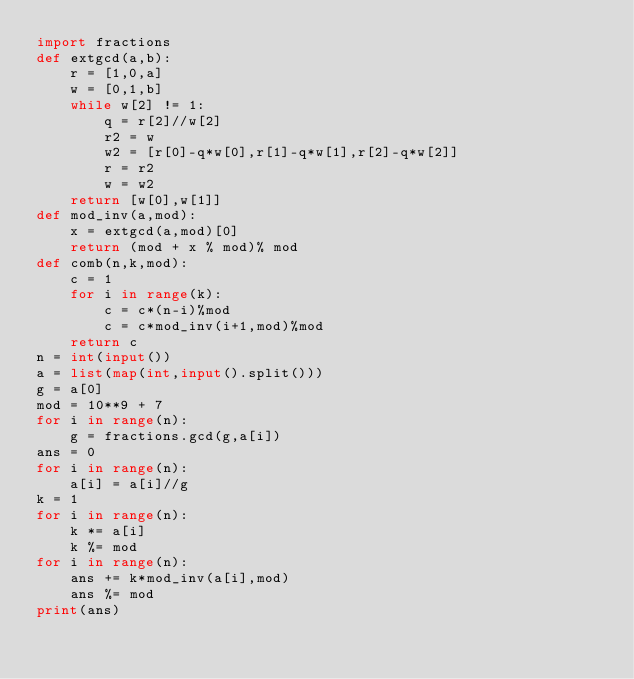<code> <loc_0><loc_0><loc_500><loc_500><_Python_>import fractions
def extgcd(a,b):
    r = [1,0,a]
    w = [0,1,b]
    while w[2] != 1:
        q = r[2]//w[2]
        r2 = w
        w2 = [r[0]-q*w[0],r[1]-q*w[1],r[2]-q*w[2]]
        r = r2
        w = w2
    return [w[0],w[1]]
def mod_inv(a,mod):
    x = extgcd(a,mod)[0]
    return (mod + x % mod)% mod
def comb(n,k,mod):
    c = 1
    for i in range(k):
        c = c*(n-i)%mod
        c = c*mod_inv(i+1,mod)%mod
    return c
n = int(input())
a = list(map(int,input().split()))
g = a[0]
mod = 10**9 + 7
for i in range(n):
    g = fractions.gcd(g,a[i])
ans = 0
for i in range(n):
    a[i] = a[i]//g
k = 1
for i in range(n):
    k *= a[i]
    k %= mod
for i in range(n):
    ans += k*mod_inv(a[i],mod)
    ans %= mod
print(ans)</code> 